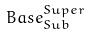Convert formula to latex. <formula><loc_0><loc_0><loc_500><loc_500>B a s e _ { S u b } ^ { S u p e r }</formula> 